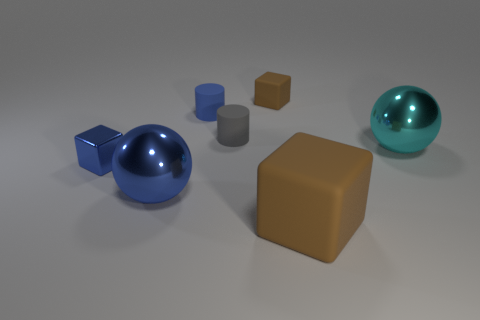Is the big blue thing made of the same material as the big sphere right of the big brown thing?
Make the answer very short. Yes. How many other objects are there of the same size as the cyan metallic thing?
Offer a very short reply. 2. There is a cyan metallic ball that is right of the large object that is left of the gray rubber cylinder; is there a cylinder on the right side of it?
Ensure brevity in your answer.  No. What is the size of the blue sphere?
Offer a terse response. Large. What size is the block behind the large cyan thing?
Offer a terse response. Small. There is a rubber thing in front of the shiny cube; does it have the same size as the gray matte cylinder?
Provide a short and direct response. No. Are there any other things that are the same color as the big rubber cube?
Give a very brief answer. Yes. What shape is the big brown matte thing?
Offer a very short reply. Cube. How many objects are to the right of the gray matte cylinder and behind the tiny blue metal block?
Give a very brief answer. 2. Do the metal block and the tiny matte block have the same color?
Give a very brief answer. No. 